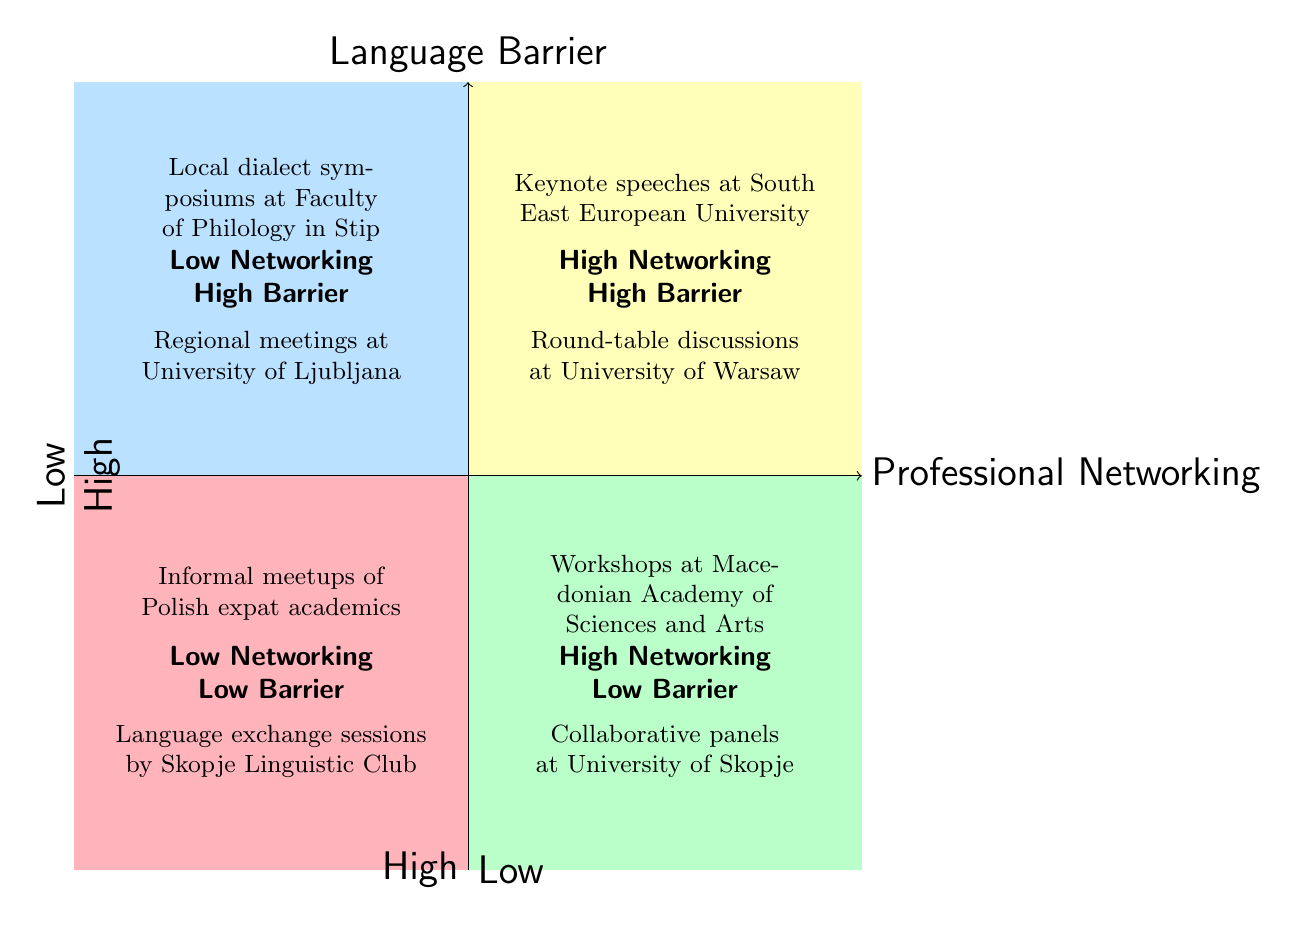What is in the High Professional Networking, High Language Barrier quadrant? The High Professional Networking, High Language Barrier quadrant contains the "Keynote speeches in English at South East European University" and "Round-table discussions at the University of Warsaw." Both are listed explicitly in this section of the diagram.
Answer: Keynote speeches in English at South East European University, Round-table discussions at the University of Warsaw How many opportunities are listed in the Low Professional Networking, Low Language Barrier quadrant? In the Low Professional Networking, Low Language Barrier quadrant, there are two opportunities: "Informal meetups of Polish expat academics in Skopje" and "Language exchange sessions organized by the Skopje Linguistic Club." Therefore, the total number is two.
Answer: 2 Which quadrant has opportunities related to local dialect symposiums? The local dialect symposiums are listed in the Low Professional Networking, High Language Barrier quadrant according to the structure of the diagram.
Answer: Low Professional Networking, High Language Barrier Are there any opportunities in the High Professional Networking, Low Language Barrier quadrant? Yes, there are two opportunities in this quadrant: "Workshops at the Macedonian Academy of Sciences and Arts (MANU)" and "Collaborative panels at the University of Skopje with simultaneous translation services." Both are explicitly mentioned here as being in this category.
Answer: Yes What are the characteristics of the opportunities in the Low Professional Networking, High Language Barrier quadrant? The opportunities in this quadrant, like "Local dialect symposiums at smaller institutions such as Faculty of Philology in Stip" and "Regional meetings focused on Slavic languages at the University of Ljubljana," are characterized by low networking potential and high language barriers, which affects academic interactions.
Answer: Low networking, high language barrier Which quadrant would likely have the least interaction due to language concerns? The quadrant with the least interaction due to language concerns is the Low Professional Networking, High Language Barrier quadrant, where local dialect events limit professional networking because of language barriers.
Answer: Low Professional Networking, High Language Barrier What distinguishes the High Professional Networking, Low Language Barrier quadrant from others? This quadrant is distinguished by having high professional networking opportunities while maintaining a low language barrier, as evidenced by "Workshops at the Macedonian Academy of Sciences and Arts (MANU)," allowing for effective collaboration across languages.
Answer: High professional networking, low language barrier How many opportunities are explicitly described in the diagram? By counting all the opportunities listed in each of the four quadrants, we find there are a total of eight opportunities provided in the entire diagram. Thus, the answer is eight.
Answer: 8 